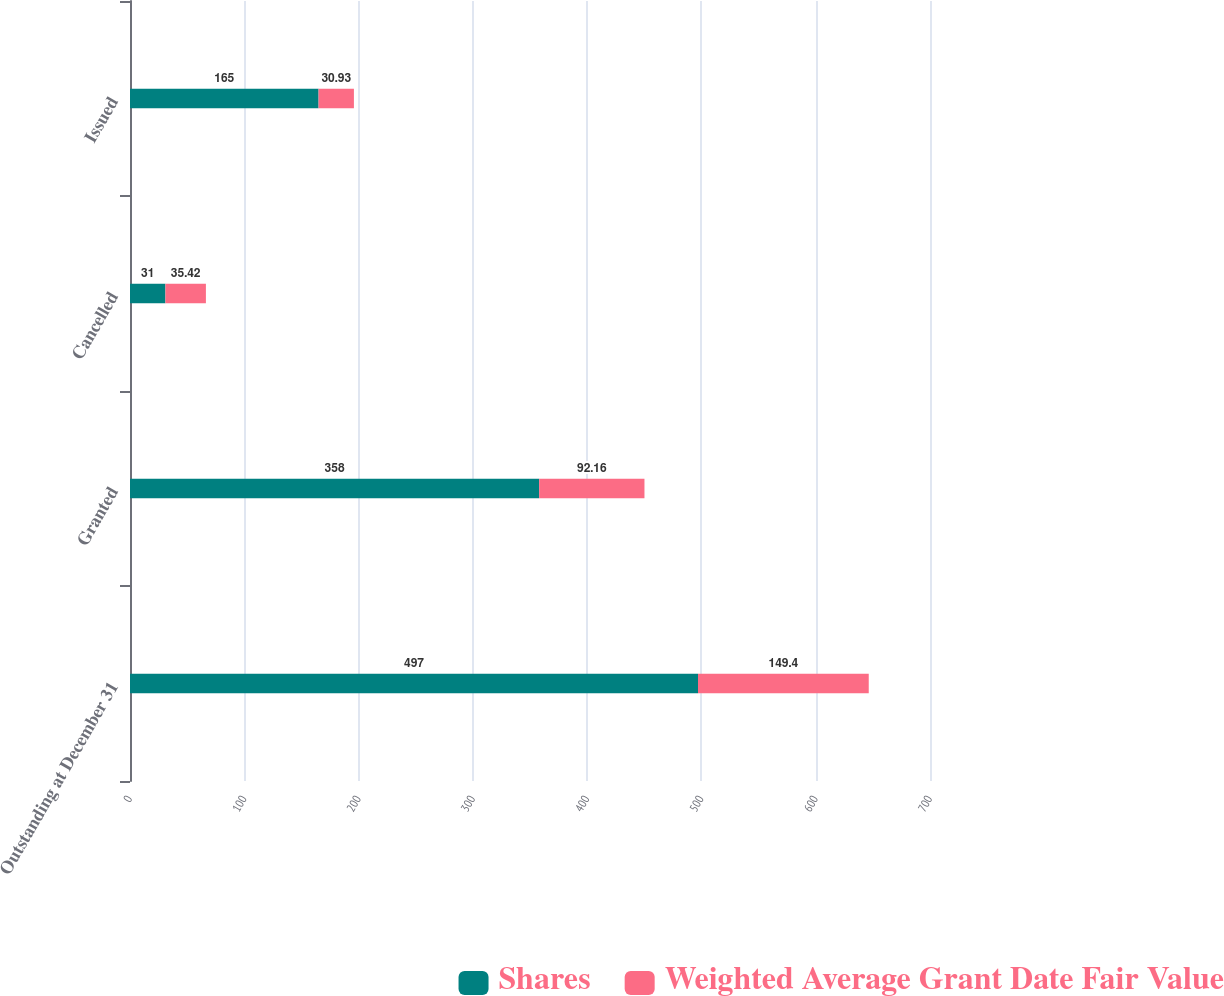Convert chart to OTSL. <chart><loc_0><loc_0><loc_500><loc_500><stacked_bar_chart><ecel><fcel>Outstanding at December 31<fcel>Granted<fcel>Cancelled<fcel>Issued<nl><fcel>Shares<fcel>497<fcel>358<fcel>31<fcel>165<nl><fcel>Weighted Average Grant Date Fair Value<fcel>149.4<fcel>92.16<fcel>35.42<fcel>30.93<nl></chart> 